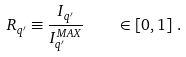Convert formula to latex. <formula><loc_0><loc_0><loc_500><loc_500>R _ { q ^ { \prime } } \equiv \frac { I _ { q ^ { \prime } } } { I _ { q ^ { \prime } } ^ { M A X } } \quad \in \left [ 0 , 1 \right ] \, .</formula> 